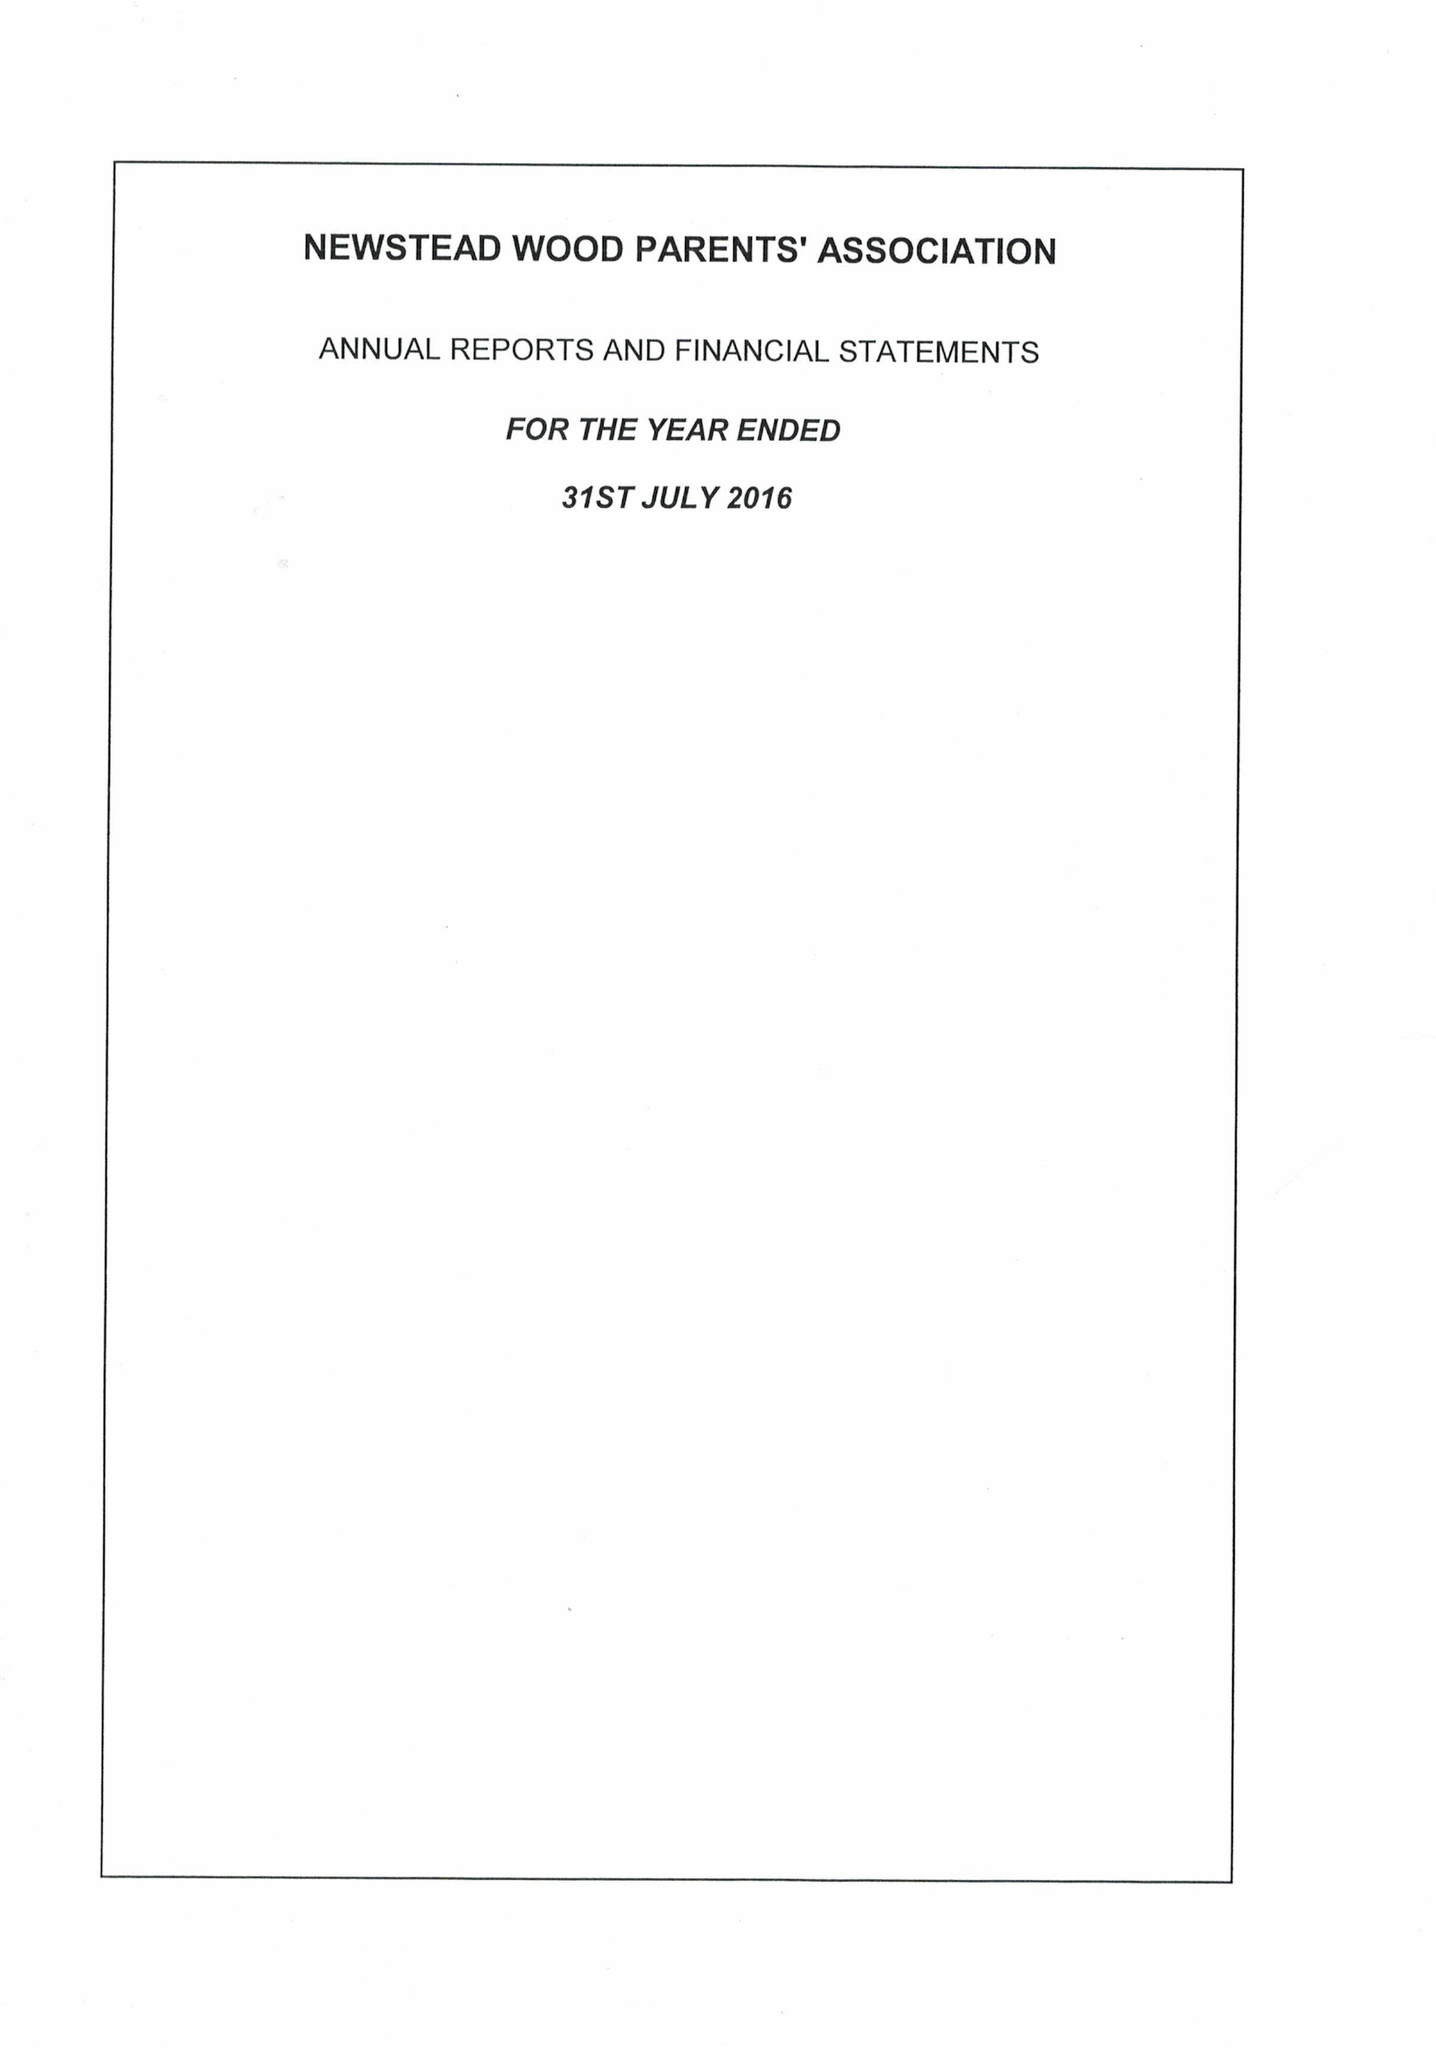What is the value for the spending_annually_in_british_pounds?
Answer the question using a single word or phrase. 63056.00 